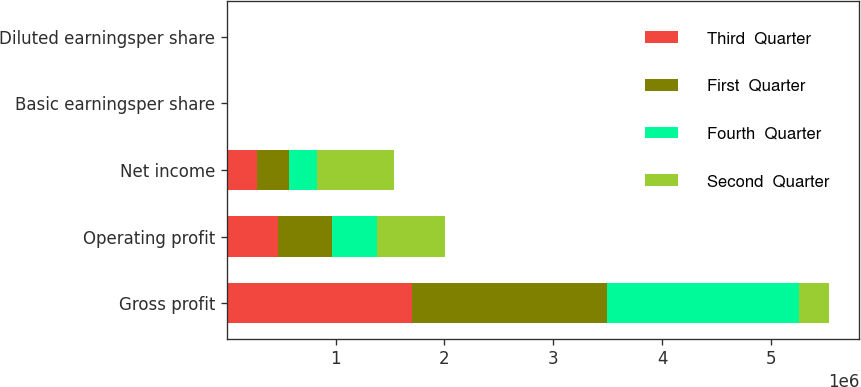Convert chart. <chart><loc_0><loc_0><loc_500><loc_500><stacked_bar_chart><ecel><fcel>Gross profit<fcel>Operating profit<fcel>Net income<fcel>Basic earningsper share<fcel>Diluted earningsper share<nl><fcel>Third  Quarter<fcel>1.69898e+06<fcel>473795<fcel>279489<fcel>1.02<fcel>1.02<nl><fcel>First  Quarter<fcel>1.79052e+06<fcel>493146<fcel>294783<fcel>1.08<fcel>1.08<nl><fcel>Fourth  Quarter<fcel>1.76646e+06<fcel>417431<fcel>252533<fcel>0.93<fcel>0.93<nl><fcel>Second  Quarter<fcel>279489<fcel>623446<fcel>712155<fcel>2.63<fcel>2.63<nl></chart> 